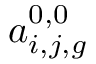<formula> <loc_0><loc_0><loc_500><loc_500>a _ { i , j , g } ^ { 0 , 0 }</formula> 